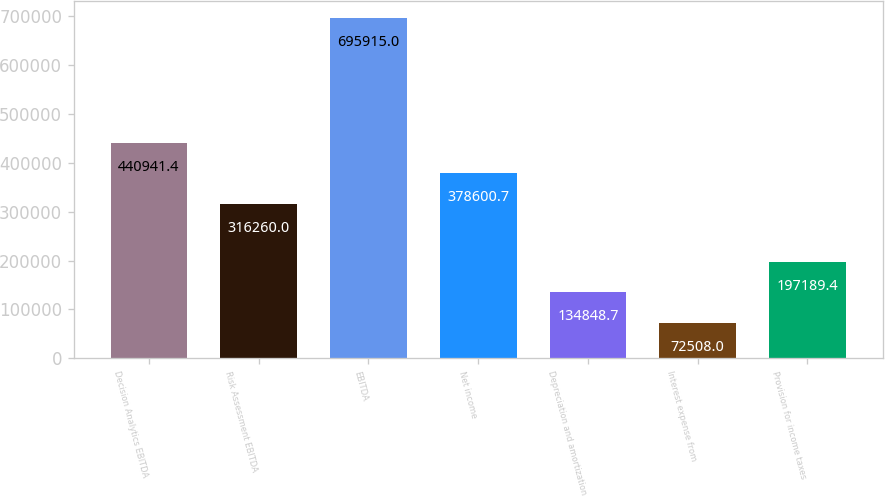Convert chart. <chart><loc_0><loc_0><loc_500><loc_500><bar_chart><fcel>Decision Analytics EBITDA<fcel>Risk Assessment EBITDA<fcel>EBITDA<fcel>Net income<fcel>Depreciation and amortization<fcel>Interest expense from<fcel>Provision for income taxes<nl><fcel>440941<fcel>316260<fcel>695915<fcel>378601<fcel>134849<fcel>72508<fcel>197189<nl></chart> 